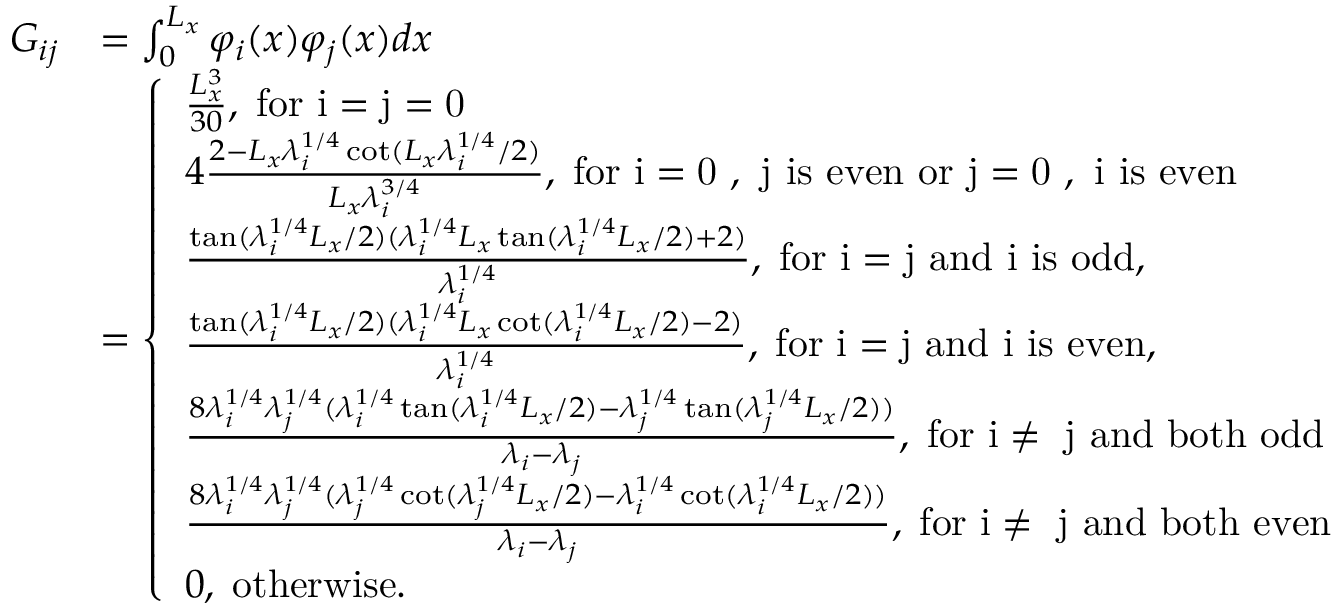Convert formula to latex. <formula><loc_0><loc_0><loc_500><loc_500>\begin{array} { r l } { G _ { i j } } & { = \int _ { 0 } ^ { L _ { x } } \varphi _ { i } ( x ) \varphi _ { j } ( x ) d x } \\ & { = \left \{ \begin{array} { l l } { \frac { L _ { x } ^ { 3 } } { 3 0 } , \, f o r i = j = 0 } \\ { 4 \frac { 2 - L _ { x } \lambda _ { i } ^ { 1 / 4 } \cot ( L _ { x } \lambda _ { i } ^ { 1 / 4 } / 2 ) } { L _ { x } \lambda _ { i } ^ { 3 / 4 } } , \, f o r i = 0 , j i s e v e n o r j = 0 , i i s e v e n } \\ { \frac { \tan ( \lambda _ { i } ^ { 1 / 4 } L _ { x } / 2 ) ( \lambda _ { i } ^ { 1 / 4 } L _ { x } \tan ( \lambda _ { i } ^ { 1 / 4 } L _ { x } / 2 ) + 2 ) } { \lambda _ { i } ^ { 1 / 4 } } , \, f o r i = j a n d i i s o d d , } \\ { \frac { \tan ( \lambda _ { i } ^ { 1 / 4 } L _ { x } / 2 ) ( \lambda _ { i } ^ { 1 / 4 } L _ { x } \cot ( \lambda _ { i } ^ { 1 / 4 } L _ { x } / 2 ) - 2 ) } { \lambda _ { i } ^ { 1 / 4 } } , \, f o r i = j a n d i i s e v e n , } \\ { \frac { 8 \lambda _ { i } ^ { 1 / 4 } \lambda _ { j } ^ { 1 / 4 } ( \lambda _ { i } ^ { 1 / 4 } \tan ( \lambda _ { i } ^ { 1 / 4 } L _ { x } / 2 ) - \lambda _ { j } ^ { 1 / 4 } \tan ( \lambda _ { j } ^ { 1 / 4 } L _ { x } / 2 ) ) } { \lambda _ { i } - \lambda _ { j } } , \, f o r i \neq j a n d b o t h o d d } \\ { \frac { 8 \lambda _ { i } ^ { 1 / 4 } \lambda _ { j } ^ { 1 / 4 } ( \lambda _ { j } ^ { 1 / 4 } \cot ( \lambda _ { j } ^ { 1 / 4 } L _ { x } / 2 ) - \lambda _ { i } ^ { 1 / 4 } \cot ( \lambda _ { i } ^ { 1 / 4 } L _ { x } / 2 ) ) } { \lambda _ { i } - \lambda _ { j } } , \, f o r i \neq j a n d b o t h e v e n } \\ { 0 , \, o t h e r w i s e . } \end{array} } \end{array}</formula> 